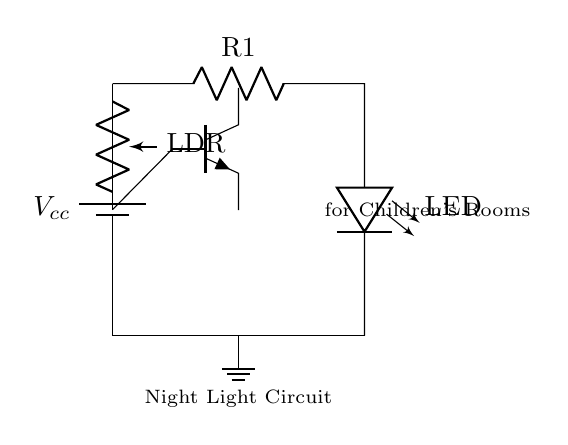What is the primary function of the photoresistor in this circuit? The photoresistor senses ambient light levels, allowing the circuit to turn on the LED when it is dark.
Answer: ambient light detection What type of LED is used in this circuit? The circuit diagram shows a standard LED which is indicated by the symbol in the circuit.
Answer: LED How many components are involved in this circuit? The diagram includes five main components: a battery, LED, resistor, transistor, and photoresistor.
Answer: five What is the purpose of the transistor in this circuit? The transistor acts as a switch that amplifies the signal from the photoresistor to control the LED based on light levels.
Answer: switch What is the role of the resistor labeled R1? The resistor limits the current flowing through the LED to protect it from burning out.
Answer: current limiting In this circuit, when will the LED turn on? The LED will turn on when the ambient light level is low, causing a change in resistance in the photoresistor that activates the transistor.
Answer: low ambient light Is this circuit designed for high power or low power applications? This is a low power circuit, suitable for small appliances like night lights for children's rooms.
Answer: low power 